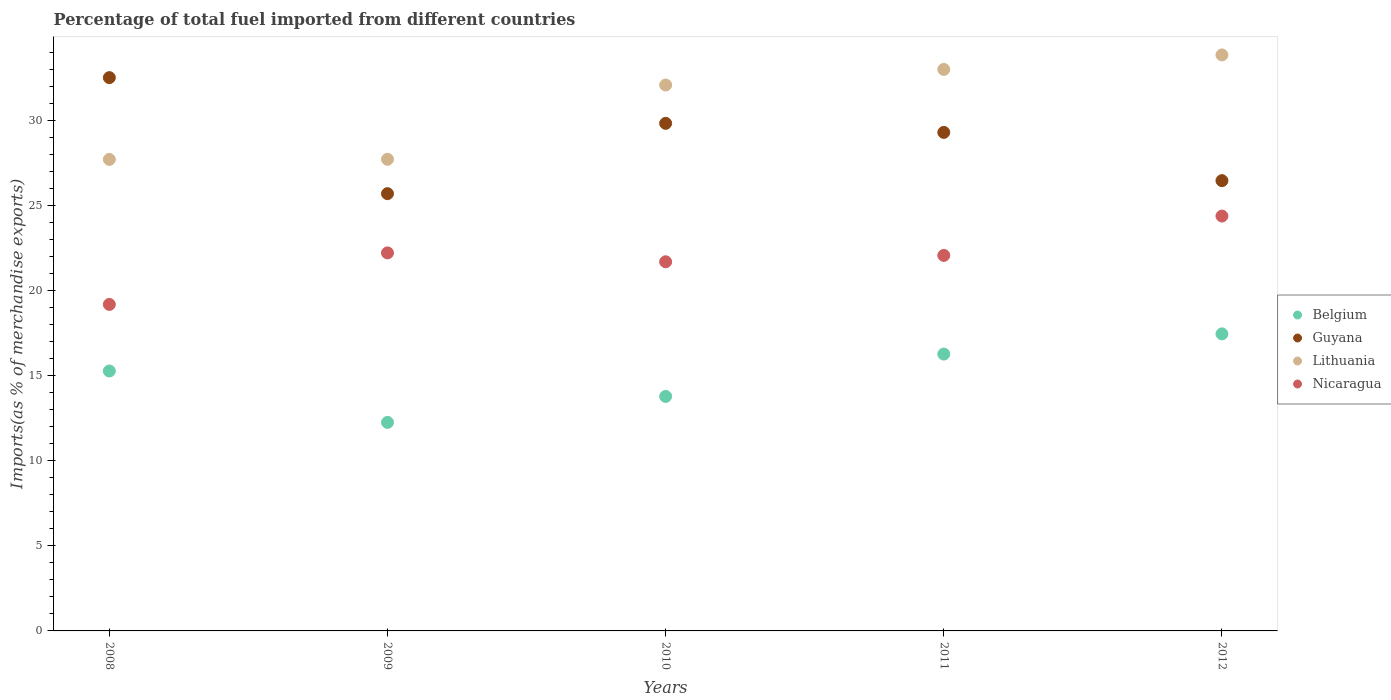Is the number of dotlines equal to the number of legend labels?
Your answer should be compact. Yes. What is the percentage of imports to different countries in Lithuania in 2009?
Make the answer very short. 27.74. Across all years, what is the maximum percentage of imports to different countries in Guyana?
Make the answer very short. 32.54. Across all years, what is the minimum percentage of imports to different countries in Nicaragua?
Provide a short and direct response. 19.2. In which year was the percentage of imports to different countries in Guyana maximum?
Keep it short and to the point. 2008. What is the total percentage of imports to different countries in Lithuania in the graph?
Offer a very short reply. 154.49. What is the difference between the percentage of imports to different countries in Lithuania in 2008 and that in 2010?
Give a very brief answer. -4.38. What is the difference between the percentage of imports to different countries in Belgium in 2011 and the percentage of imports to different countries in Nicaragua in 2009?
Your answer should be very brief. -5.95. What is the average percentage of imports to different countries in Guyana per year?
Provide a short and direct response. 28.78. In the year 2011, what is the difference between the percentage of imports to different countries in Belgium and percentage of imports to different countries in Nicaragua?
Provide a succinct answer. -5.8. What is the ratio of the percentage of imports to different countries in Belgium in 2008 to that in 2011?
Your answer should be very brief. 0.94. Is the percentage of imports to different countries in Belgium in 2008 less than that in 2010?
Your response must be concise. No. Is the difference between the percentage of imports to different countries in Belgium in 2010 and 2012 greater than the difference between the percentage of imports to different countries in Nicaragua in 2010 and 2012?
Your answer should be compact. No. What is the difference between the highest and the second highest percentage of imports to different countries in Guyana?
Offer a terse response. 2.69. What is the difference between the highest and the lowest percentage of imports to different countries in Lithuania?
Provide a short and direct response. 6.14. Is the sum of the percentage of imports to different countries in Nicaragua in 2008 and 2010 greater than the maximum percentage of imports to different countries in Belgium across all years?
Keep it short and to the point. Yes. Is it the case that in every year, the sum of the percentage of imports to different countries in Lithuania and percentage of imports to different countries in Nicaragua  is greater than the sum of percentage of imports to different countries in Belgium and percentage of imports to different countries in Guyana?
Your answer should be compact. Yes. Is the percentage of imports to different countries in Lithuania strictly greater than the percentage of imports to different countries in Belgium over the years?
Keep it short and to the point. Yes. How many dotlines are there?
Your response must be concise. 4. How many years are there in the graph?
Keep it short and to the point. 5. Where does the legend appear in the graph?
Keep it short and to the point. Center right. What is the title of the graph?
Your answer should be compact. Percentage of total fuel imported from different countries. What is the label or title of the Y-axis?
Your response must be concise. Imports(as % of merchandise exports). What is the Imports(as % of merchandise exports) of Belgium in 2008?
Your response must be concise. 15.29. What is the Imports(as % of merchandise exports) in Guyana in 2008?
Offer a very short reply. 32.54. What is the Imports(as % of merchandise exports) of Lithuania in 2008?
Your response must be concise. 27.73. What is the Imports(as % of merchandise exports) in Nicaragua in 2008?
Your answer should be compact. 19.2. What is the Imports(as % of merchandise exports) of Belgium in 2009?
Give a very brief answer. 12.27. What is the Imports(as % of merchandise exports) in Guyana in 2009?
Provide a short and direct response. 25.72. What is the Imports(as % of merchandise exports) of Lithuania in 2009?
Keep it short and to the point. 27.74. What is the Imports(as % of merchandise exports) in Nicaragua in 2009?
Your answer should be very brief. 22.24. What is the Imports(as % of merchandise exports) of Belgium in 2010?
Offer a terse response. 13.79. What is the Imports(as % of merchandise exports) of Guyana in 2010?
Your answer should be very brief. 29.85. What is the Imports(as % of merchandise exports) of Lithuania in 2010?
Keep it short and to the point. 32.11. What is the Imports(as % of merchandise exports) of Nicaragua in 2010?
Provide a succinct answer. 21.71. What is the Imports(as % of merchandise exports) of Belgium in 2011?
Offer a terse response. 16.28. What is the Imports(as % of merchandise exports) in Guyana in 2011?
Give a very brief answer. 29.32. What is the Imports(as % of merchandise exports) in Lithuania in 2011?
Offer a very short reply. 33.03. What is the Imports(as % of merchandise exports) of Nicaragua in 2011?
Offer a terse response. 22.09. What is the Imports(as % of merchandise exports) in Belgium in 2012?
Keep it short and to the point. 17.47. What is the Imports(as % of merchandise exports) in Guyana in 2012?
Your answer should be very brief. 26.48. What is the Imports(as % of merchandise exports) of Lithuania in 2012?
Give a very brief answer. 33.88. What is the Imports(as % of merchandise exports) of Nicaragua in 2012?
Your answer should be very brief. 24.4. Across all years, what is the maximum Imports(as % of merchandise exports) in Belgium?
Make the answer very short. 17.47. Across all years, what is the maximum Imports(as % of merchandise exports) of Guyana?
Give a very brief answer. 32.54. Across all years, what is the maximum Imports(as % of merchandise exports) of Lithuania?
Your answer should be very brief. 33.88. Across all years, what is the maximum Imports(as % of merchandise exports) in Nicaragua?
Offer a very short reply. 24.4. Across all years, what is the minimum Imports(as % of merchandise exports) in Belgium?
Your response must be concise. 12.27. Across all years, what is the minimum Imports(as % of merchandise exports) in Guyana?
Provide a succinct answer. 25.72. Across all years, what is the minimum Imports(as % of merchandise exports) of Lithuania?
Give a very brief answer. 27.73. Across all years, what is the minimum Imports(as % of merchandise exports) of Nicaragua?
Keep it short and to the point. 19.2. What is the total Imports(as % of merchandise exports) in Belgium in the graph?
Make the answer very short. 75.1. What is the total Imports(as % of merchandise exports) of Guyana in the graph?
Your answer should be very brief. 143.92. What is the total Imports(as % of merchandise exports) in Lithuania in the graph?
Provide a succinct answer. 154.49. What is the total Imports(as % of merchandise exports) of Nicaragua in the graph?
Provide a succinct answer. 109.64. What is the difference between the Imports(as % of merchandise exports) of Belgium in 2008 and that in 2009?
Keep it short and to the point. 3.02. What is the difference between the Imports(as % of merchandise exports) of Guyana in 2008 and that in 2009?
Provide a succinct answer. 6.82. What is the difference between the Imports(as % of merchandise exports) of Lithuania in 2008 and that in 2009?
Your answer should be compact. -0.01. What is the difference between the Imports(as % of merchandise exports) of Nicaragua in 2008 and that in 2009?
Offer a very short reply. -3.03. What is the difference between the Imports(as % of merchandise exports) in Belgium in 2008 and that in 2010?
Keep it short and to the point. 1.49. What is the difference between the Imports(as % of merchandise exports) of Guyana in 2008 and that in 2010?
Your answer should be very brief. 2.69. What is the difference between the Imports(as % of merchandise exports) of Lithuania in 2008 and that in 2010?
Ensure brevity in your answer.  -4.38. What is the difference between the Imports(as % of merchandise exports) of Nicaragua in 2008 and that in 2010?
Give a very brief answer. -2.51. What is the difference between the Imports(as % of merchandise exports) of Belgium in 2008 and that in 2011?
Offer a very short reply. -1. What is the difference between the Imports(as % of merchandise exports) in Guyana in 2008 and that in 2011?
Ensure brevity in your answer.  3.22. What is the difference between the Imports(as % of merchandise exports) in Lithuania in 2008 and that in 2011?
Your response must be concise. -5.29. What is the difference between the Imports(as % of merchandise exports) of Nicaragua in 2008 and that in 2011?
Offer a very short reply. -2.88. What is the difference between the Imports(as % of merchandise exports) in Belgium in 2008 and that in 2012?
Provide a succinct answer. -2.18. What is the difference between the Imports(as % of merchandise exports) of Guyana in 2008 and that in 2012?
Your response must be concise. 6.06. What is the difference between the Imports(as % of merchandise exports) of Lithuania in 2008 and that in 2012?
Ensure brevity in your answer.  -6.14. What is the difference between the Imports(as % of merchandise exports) of Nicaragua in 2008 and that in 2012?
Keep it short and to the point. -5.2. What is the difference between the Imports(as % of merchandise exports) in Belgium in 2009 and that in 2010?
Your answer should be very brief. -1.53. What is the difference between the Imports(as % of merchandise exports) of Guyana in 2009 and that in 2010?
Give a very brief answer. -4.14. What is the difference between the Imports(as % of merchandise exports) of Lithuania in 2009 and that in 2010?
Your answer should be compact. -4.37. What is the difference between the Imports(as % of merchandise exports) in Nicaragua in 2009 and that in 2010?
Ensure brevity in your answer.  0.52. What is the difference between the Imports(as % of merchandise exports) in Belgium in 2009 and that in 2011?
Your answer should be compact. -4.02. What is the difference between the Imports(as % of merchandise exports) in Guyana in 2009 and that in 2011?
Make the answer very short. -3.6. What is the difference between the Imports(as % of merchandise exports) in Lithuania in 2009 and that in 2011?
Offer a very short reply. -5.29. What is the difference between the Imports(as % of merchandise exports) of Nicaragua in 2009 and that in 2011?
Ensure brevity in your answer.  0.15. What is the difference between the Imports(as % of merchandise exports) in Belgium in 2009 and that in 2012?
Provide a succinct answer. -5.21. What is the difference between the Imports(as % of merchandise exports) in Guyana in 2009 and that in 2012?
Give a very brief answer. -0.76. What is the difference between the Imports(as % of merchandise exports) of Lithuania in 2009 and that in 2012?
Offer a terse response. -6.14. What is the difference between the Imports(as % of merchandise exports) in Nicaragua in 2009 and that in 2012?
Give a very brief answer. -2.17. What is the difference between the Imports(as % of merchandise exports) in Belgium in 2010 and that in 2011?
Provide a succinct answer. -2.49. What is the difference between the Imports(as % of merchandise exports) in Guyana in 2010 and that in 2011?
Your answer should be very brief. 0.53. What is the difference between the Imports(as % of merchandise exports) in Lithuania in 2010 and that in 2011?
Provide a succinct answer. -0.92. What is the difference between the Imports(as % of merchandise exports) in Nicaragua in 2010 and that in 2011?
Make the answer very short. -0.37. What is the difference between the Imports(as % of merchandise exports) in Belgium in 2010 and that in 2012?
Your answer should be very brief. -3.68. What is the difference between the Imports(as % of merchandise exports) in Guyana in 2010 and that in 2012?
Provide a short and direct response. 3.37. What is the difference between the Imports(as % of merchandise exports) of Lithuania in 2010 and that in 2012?
Your response must be concise. -1.77. What is the difference between the Imports(as % of merchandise exports) of Nicaragua in 2010 and that in 2012?
Ensure brevity in your answer.  -2.69. What is the difference between the Imports(as % of merchandise exports) in Belgium in 2011 and that in 2012?
Keep it short and to the point. -1.19. What is the difference between the Imports(as % of merchandise exports) in Guyana in 2011 and that in 2012?
Keep it short and to the point. 2.84. What is the difference between the Imports(as % of merchandise exports) in Lithuania in 2011 and that in 2012?
Offer a terse response. -0.85. What is the difference between the Imports(as % of merchandise exports) in Nicaragua in 2011 and that in 2012?
Give a very brief answer. -2.31. What is the difference between the Imports(as % of merchandise exports) of Belgium in 2008 and the Imports(as % of merchandise exports) of Guyana in 2009?
Your response must be concise. -10.43. What is the difference between the Imports(as % of merchandise exports) in Belgium in 2008 and the Imports(as % of merchandise exports) in Lithuania in 2009?
Give a very brief answer. -12.45. What is the difference between the Imports(as % of merchandise exports) in Belgium in 2008 and the Imports(as % of merchandise exports) in Nicaragua in 2009?
Offer a very short reply. -6.95. What is the difference between the Imports(as % of merchandise exports) of Guyana in 2008 and the Imports(as % of merchandise exports) of Lithuania in 2009?
Give a very brief answer. 4.8. What is the difference between the Imports(as % of merchandise exports) in Guyana in 2008 and the Imports(as % of merchandise exports) in Nicaragua in 2009?
Provide a short and direct response. 10.31. What is the difference between the Imports(as % of merchandise exports) in Lithuania in 2008 and the Imports(as % of merchandise exports) in Nicaragua in 2009?
Offer a terse response. 5.5. What is the difference between the Imports(as % of merchandise exports) of Belgium in 2008 and the Imports(as % of merchandise exports) of Guyana in 2010?
Offer a terse response. -14.57. What is the difference between the Imports(as % of merchandise exports) of Belgium in 2008 and the Imports(as % of merchandise exports) of Lithuania in 2010?
Offer a terse response. -16.82. What is the difference between the Imports(as % of merchandise exports) of Belgium in 2008 and the Imports(as % of merchandise exports) of Nicaragua in 2010?
Give a very brief answer. -6.42. What is the difference between the Imports(as % of merchandise exports) in Guyana in 2008 and the Imports(as % of merchandise exports) in Lithuania in 2010?
Ensure brevity in your answer.  0.43. What is the difference between the Imports(as % of merchandise exports) in Guyana in 2008 and the Imports(as % of merchandise exports) in Nicaragua in 2010?
Your answer should be compact. 10.83. What is the difference between the Imports(as % of merchandise exports) in Lithuania in 2008 and the Imports(as % of merchandise exports) in Nicaragua in 2010?
Your response must be concise. 6.02. What is the difference between the Imports(as % of merchandise exports) in Belgium in 2008 and the Imports(as % of merchandise exports) in Guyana in 2011?
Your response must be concise. -14.03. What is the difference between the Imports(as % of merchandise exports) in Belgium in 2008 and the Imports(as % of merchandise exports) in Lithuania in 2011?
Provide a succinct answer. -17.74. What is the difference between the Imports(as % of merchandise exports) in Belgium in 2008 and the Imports(as % of merchandise exports) in Nicaragua in 2011?
Keep it short and to the point. -6.8. What is the difference between the Imports(as % of merchandise exports) in Guyana in 2008 and the Imports(as % of merchandise exports) in Lithuania in 2011?
Provide a short and direct response. -0.48. What is the difference between the Imports(as % of merchandise exports) in Guyana in 2008 and the Imports(as % of merchandise exports) in Nicaragua in 2011?
Provide a short and direct response. 10.46. What is the difference between the Imports(as % of merchandise exports) in Lithuania in 2008 and the Imports(as % of merchandise exports) in Nicaragua in 2011?
Provide a succinct answer. 5.65. What is the difference between the Imports(as % of merchandise exports) in Belgium in 2008 and the Imports(as % of merchandise exports) in Guyana in 2012?
Your answer should be compact. -11.2. What is the difference between the Imports(as % of merchandise exports) in Belgium in 2008 and the Imports(as % of merchandise exports) in Lithuania in 2012?
Make the answer very short. -18.59. What is the difference between the Imports(as % of merchandise exports) of Belgium in 2008 and the Imports(as % of merchandise exports) of Nicaragua in 2012?
Ensure brevity in your answer.  -9.11. What is the difference between the Imports(as % of merchandise exports) of Guyana in 2008 and the Imports(as % of merchandise exports) of Lithuania in 2012?
Provide a succinct answer. -1.33. What is the difference between the Imports(as % of merchandise exports) in Guyana in 2008 and the Imports(as % of merchandise exports) in Nicaragua in 2012?
Offer a very short reply. 8.14. What is the difference between the Imports(as % of merchandise exports) in Lithuania in 2008 and the Imports(as % of merchandise exports) in Nicaragua in 2012?
Make the answer very short. 3.33. What is the difference between the Imports(as % of merchandise exports) of Belgium in 2009 and the Imports(as % of merchandise exports) of Guyana in 2010?
Keep it short and to the point. -17.59. What is the difference between the Imports(as % of merchandise exports) in Belgium in 2009 and the Imports(as % of merchandise exports) in Lithuania in 2010?
Your response must be concise. -19.84. What is the difference between the Imports(as % of merchandise exports) of Belgium in 2009 and the Imports(as % of merchandise exports) of Nicaragua in 2010?
Your response must be concise. -9.45. What is the difference between the Imports(as % of merchandise exports) of Guyana in 2009 and the Imports(as % of merchandise exports) of Lithuania in 2010?
Your answer should be compact. -6.39. What is the difference between the Imports(as % of merchandise exports) of Guyana in 2009 and the Imports(as % of merchandise exports) of Nicaragua in 2010?
Keep it short and to the point. 4.01. What is the difference between the Imports(as % of merchandise exports) of Lithuania in 2009 and the Imports(as % of merchandise exports) of Nicaragua in 2010?
Make the answer very short. 6.03. What is the difference between the Imports(as % of merchandise exports) in Belgium in 2009 and the Imports(as % of merchandise exports) in Guyana in 2011?
Provide a succinct answer. -17.06. What is the difference between the Imports(as % of merchandise exports) in Belgium in 2009 and the Imports(as % of merchandise exports) in Lithuania in 2011?
Offer a terse response. -20.76. What is the difference between the Imports(as % of merchandise exports) in Belgium in 2009 and the Imports(as % of merchandise exports) in Nicaragua in 2011?
Your response must be concise. -9.82. What is the difference between the Imports(as % of merchandise exports) in Guyana in 2009 and the Imports(as % of merchandise exports) in Lithuania in 2011?
Keep it short and to the point. -7.31. What is the difference between the Imports(as % of merchandise exports) of Guyana in 2009 and the Imports(as % of merchandise exports) of Nicaragua in 2011?
Your answer should be very brief. 3.63. What is the difference between the Imports(as % of merchandise exports) in Lithuania in 2009 and the Imports(as % of merchandise exports) in Nicaragua in 2011?
Offer a terse response. 5.65. What is the difference between the Imports(as % of merchandise exports) in Belgium in 2009 and the Imports(as % of merchandise exports) in Guyana in 2012?
Ensure brevity in your answer.  -14.22. What is the difference between the Imports(as % of merchandise exports) in Belgium in 2009 and the Imports(as % of merchandise exports) in Lithuania in 2012?
Provide a succinct answer. -21.61. What is the difference between the Imports(as % of merchandise exports) in Belgium in 2009 and the Imports(as % of merchandise exports) in Nicaragua in 2012?
Offer a terse response. -12.14. What is the difference between the Imports(as % of merchandise exports) of Guyana in 2009 and the Imports(as % of merchandise exports) of Lithuania in 2012?
Your answer should be very brief. -8.16. What is the difference between the Imports(as % of merchandise exports) in Guyana in 2009 and the Imports(as % of merchandise exports) in Nicaragua in 2012?
Your answer should be compact. 1.32. What is the difference between the Imports(as % of merchandise exports) of Lithuania in 2009 and the Imports(as % of merchandise exports) of Nicaragua in 2012?
Your answer should be compact. 3.34. What is the difference between the Imports(as % of merchandise exports) in Belgium in 2010 and the Imports(as % of merchandise exports) in Guyana in 2011?
Keep it short and to the point. -15.53. What is the difference between the Imports(as % of merchandise exports) of Belgium in 2010 and the Imports(as % of merchandise exports) of Lithuania in 2011?
Your response must be concise. -19.23. What is the difference between the Imports(as % of merchandise exports) in Belgium in 2010 and the Imports(as % of merchandise exports) in Nicaragua in 2011?
Provide a succinct answer. -8.29. What is the difference between the Imports(as % of merchandise exports) in Guyana in 2010 and the Imports(as % of merchandise exports) in Lithuania in 2011?
Keep it short and to the point. -3.17. What is the difference between the Imports(as % of merchandise exports) in Guyana in 2010 and the Imports(as % of merchandise exports) in Nicaragua in 2011?
Your answer should be very brief. 7.77. What is the difference between the Imports(as % of merchandise exports) in Lithuania in 2010 and the Imports(as % of merchandise exports) in Nicaragua in 2011?
Your answer should be very brief. 10.02. What is the difference between the Imports(as % of merchandise exports) in Belgium in 2010 and the Imports(as % of merchandise exports) in Guyana in 2012?
Provide a short and direct response. -12.69. What is the difference between the Imports(as % of merchandise exports) of Belgium in 2010 and the Imports(as % of merchandise exports) of Lithuania in 2012?
Provide a succinct answer. -20.08. What is the difference between the Imports(as % of merchandise exports) of Belgium in 2010 and the Imports(as % of merchandise exports) of Nicaragua in 2012?
Your answer should be very brief. -10.61. What is the difference between the Imports(as % of merchandise exports) of Guyana in 2010 and the Imports(as % of merchandise exports) of Lithuania in 2012?
Your answer should be compact. -4.02. What is the difference between the Imports(as % of merchandise exports) of Guyana in 2010 and the Imports(as % of merchandise exports) of Nicaragua in 2012?
Your answer should be very brief. 5.45. What is the difference between the Imports(as % of merchandise exports) in Lithuania in 2010 and the Imports(as % of merchandise exports) in Nicaragua in 2012?
Your answer should be compact. 7.71. What is the difference between the Imports(as % of merchandise exports) in Belgium in 2011 and the Imports(as % of merchandise exports) in Guyana in 2012?
Make the answer very short. -10.2. What is the difference between the Imports(as % of merchandise exports) of Belgium in 2011 and the Imports(as % of merchandise exports) of Lithuania in 2012?
Provide a short and direct response. -17.59. What is the difference between the Imports(as % of merchandise exports) of Belgium in 2011 and the Imports(as % of merchandise exports) of Nicaragua in 2012?
Provide a short and direct response. -8.12. What is the difference between the Imports(as % of merchandise exports) of Guyana in 2011 and the Imports(as % of merchandise exports) of Lithuania in 2012?
Your answer should be very brief. -4.56. What is the difference between the Imports(as % of merchandise exports) of Guyana in 2011 and the Imports(as % of merchandise exports) of Nicaragua in 2012?
Make the answer very short. 4.92. What is the difference between the Imports(as % of merchandise exports) in Lithuania in 2011 and the Imports(as % of merchandise exports) in Nicaragua in 2012?
Ensure brevity in your answer.  8.63. What is the average Imports(as % of merchandise exports) of Belgium per year?
Your answer should be compact. 15.02. What is the average Imports(as % of merchandise exports) in Guyana per year?
Offer a terse response. 28.78. What is the average Imports(as % of merchandise exports) in Lithuania per year?
Your response must be concise. 30.9. What is the average Imports(as % of merchandise exports) of Nicaragua per year?
Provide a short and direct response. 21.93. In the year 2008, what is the difference between the Imports(as % of merchandise exports) in Belgium and Imports(as % of merchandise exports) in Guyana?
Your answer should be very brief. -17.26. In the year 2008, what is the difference between the Imports(as % of merchandise exports) in Belgium and Imports(as % of merchandise exports) in Lithuania?
Make the answer very short. -12.45. In the year 2008, what is the difference between the Imports(as % of merchandise exports) of Belgium and Imports(as % of merchandise exports) of Nicaragua?
Provide a succinct answer. -3.92. In the year 2008, what is the difference between the Imports(as % of merchandise exports) of Guyana and Imports(as % of merchandise exports) of Lithuania?
Your answer should be compact. 4.81. In the year 2008, what is the difference between the Imports(as % of merchandise exports) in Guyana and Imports(as % of merchandise exports) in Nicaragua?
Ensure brevity in your answer.  13.34. In the year 2008, what is the difference between the Imports(as % of merchandise exports) in Lithuania and Imports(as % of merchandise exports) in Nicaragua?
Your answer should be compact. 8.53. In the year 2009, what is the difference between the Imports(as % of merchandise exports) of Belgium and Imports(as % of merchandise exports) of Guyana?
Provide a succinct answer. -13.45. In the year 2009, what is the difference between the Imports(as % of merchandise exports) in Belgium and Imports(as % of merchandise exports) in Lithuania?
Your answer should be compact. -15.47. In the year 2009, what is the difference between the Imports(as % of merchandise exports) in Belgium and Imports(as % of merchandise exports) in Nicaragua?
Your response must be concise. -9.97. In the year 2009, what is the difference between the Imports(as % of merchandise exports) in Guyana and Imports(as % of merchandise exports) in Lithuania?
Provide a succinct answer. -2.02. In the year 2009, what is the difference between the Imports(as % of merchandise exports) of Guyana and Imports(as % of merchandise exports) of Nicaragua?
Provide a succinct answer. 3.48. In the year 2009, what is the difference between the Imports(as % of merchandise exports) of Lithuania and Imports(as % of merchandise exports) of Nicaragua?
Make the answer very short. 5.51. In the year 2010, what is the difference between the Imports(as % of merchandise exports) in Belgium and Imports(as % of merchandise exports) in Guyana?
Give a very brief answer. -16.06. In the year 2010, what is the difference between the Imports(as % of merchandise exports) of Belgium and Imports(as % of merchandise exports) of Lithuania?
Keep it short and to the point. -18.32. In the year 2010, what is the difference between the Imports(as % of merchandise exports) of Belgium and Imports(as % of merchandise exports) of Nicaragua?
Ensure brevity in your answer.  -7.92. In the year 2010, what is the difference between the Imports(as % of merchandise exports) of Guyana and Imports(as % of merchandise exports) of Lithuania?
Give a very brief answer. -2.25. In the year 2010, what is the difference between the Imports(as % of merchandise exports) of Guyana and Imports(as % of merchandise exports) of Nicaragua?
Keep it short and to the point. 8.14. In the year 2010, what is the difference between the Imports(as % of merchandise exports) in Lithuania and Imports(as % of merchandise exports) in Nicaragua?
Your answer should be very brief. 10.4. In the year 2011, what is the difference between the Imports(as % of merchandise exports) of Belgium and Imports(as % of merchandise exports) of Guyana?
Make the answer very short. -13.04. In the year 2011, what is the difference between the Imports(as % of merchandise exports) in Belgium and Imports(as % of merchandise exports) in Lithuania?
Your answer should be very brief. -16.74. In the year 2011, what is the difference between the Imports(as % of merchandise exports) of Belgium and Imports(as % of merchandise exports) of Nicaragua?
Offer a very short reply. -5.8. In the year 2011, what is the difference between the Imports(as % of merchandise exports) in Guyana and Imports(as % of merchandise exports) in Lithuania?
Provide a short and direct response. -3.71. In the year 2011, what is the difference between the Imports(as % of merchandise exports) of Guyana and Imports(as % of merchandise exports) of Nicaragua?
Provide a succinct answer. 7.24. In the year 2011, what is the difference between the Imports(as % of merchandise exports) of Lithuania and Imports(as % of merchandise exports) of Nicaragua?
Make the answer very short. 10.94. In the year 2012, what is the difference between the Imports(as % of merchandise exports) of Belgium and Imports(as % of merchandise exports) of Guyana?
Your response must be concise. -9.01. In the year 2012, what is the difference between the Imports(as % of merchandise exports) in Belgium and Imports(as % of merchandise exports) in Lithuania?
Make the answer very short. -16.41. In the year 2012, what is the difference between the Imports(as % of merchandise exports) in Belgium and Imports(as % of merchandise exports) in Nicaragua?
Ensure brevity in your answer.  -6.93. In the year 2012, what is the difference between the Imports(as % of merchandise exports) in Guyana and Imports(as % of merchandise exports) in Lithuania?
Your response must be concise. -7.39. In the year 2012, what is the difference between the Imports(as % of merchandise exports) in Guyana and Imports(as % of merchandise exports) in Nicaragua?
Provide a short and direct response. 2.08. In the year 2012, what is the difference between the Imports(as % of merchandise exports) in Lithuania and Imports(as % of merchandise exports) in Nicaragua?
Your answer should be very brief. 9.48. What is the ratio of the Imports(as % of merchandise exports) in Belgium in 2008 to that in 2009?
Make the answer very short. 1.25. What is the ratio of the Imports(as % of merchandise exports) in Guyana in 2008 to that in 2009?
Offer a terse response. 1.27. What is the ratio of the Imports(as % of merchandise exports) of Lithuania in 2008 to that in 2009?
Provide a short and direct response. 1. What is the ratio of the Imports(as % of merchandise exports) in Nicaragua in 2008 to that in 2009?
Your answer should be very brief. 0.86. What is the ratio of the Imports(as % of merchandise exports) in Belgium in 2008 to that in 2010?
Keep it short and to the point. 1.11. What is the ratio of the Imports(as % of merchandise exports) of Guyana in 2008 to that in 2010?
Offer a very short reply. 1.09. What is the ratio of the Imports(as % of merchandise exports) in Lithuania in 2008 to that in 2010?
Your answer should be compact. 0.86. What is the ratio of the Imports(as % of merchandise exports) in Nicaragua in 2008 to that in 2010?
Keep it short and to the point. 0.88. What is the ratio of the Imports(as % of merchandise exports) in Belgium in 2008 to that in 2011?
Your answer should be very brief. 0.94. What is the ratio of the Imports(as % of merchandise exports) of Guyana in 2008 to that in 2011?
Provide a succinct answer. 1.11. What is the ratio of the Imports(as % of merchandise exports) of Lithuania in 2008 to that in 2011?
Give a very brief answer. 0.84. What is the ratio of the Imports(as % of merchandise exports) in Nicaragua in 2008 to that in 2011?
Provide a short and direct response. 0.87. What is the ratio of the Imports(as % of merchandise exports) of Belgium in 2008 to that in 2012?
Your answer should be compact. 0.88. What is the ratio of the Imports(as % of merchandise exports) in Guyana in 2008 to that in 2012?
Keep it short and to the point. 1.23. What is the ratio of the Imports(as % of merchandise exports) of Lithuania in 2008 to that in 2012?
Give a very brief answer. 0.82. What is the ratio of the Imports(as % of merchandise exports) in Nicaragua in 2008 to that in 2012?
Provide a short and direct response. 0.79. What is the ratio of the Imports(as % of merchandise exports) in Belgium in 2009 to that in 2010?
Make the answer very short. 0.89. What is the ratio of the Imports(as % of merchandise exports) of Guyana in 2009 to that in 2010?
Give a very brief answer. 0.86. What is the ratio of the Imports(as % of merchandise exports) in Lithuania in 2009 to that in 2010?
Offer a very short reply. 0.86. What is the ratio of the Imports(as % of merchandise exports) in Nicaragua in 2009 to that in 2010?
Provide a succinct answer. 1.02. What is the ratio of the Imports(as % of merchandise exports) of Belgium in 2009 to that in 2011?
Offer a very short reply. 0.75. What is the ratio of the Imports(as % of merchandise exports) of Guyana in 2009 to that in 2011?
Keep it short and to the point. 0.88. What is the ratio of the Imports(as % of merchandise exports) of Lithuania in 2009 to that in 2011?
Ensure brevity in your answer.  0.84. What is the ratio of the Imports(as % of merchandise exports) in Belgium in 2009 to that in 2012?
Offer a very short reply. 0.7. What is the ratio of the Imports(as % of merchandise exports) in Guyana in 2009 to that in 2012?
Ensure brevity in your answer.  0.97. What is the ratio of the Imports(as % of merchandise exports) of Lithuania in 2009 to that in 2012?
Give a very brief answer. 0.82. What is the ratio of the Imports(as % of merchandise exports) in Nicaragua in 2009 to that in 2012?
Offer a very short reply. 0.91. What is the ratio of the Imports(as % of merchandise exports) in Belgium in 2010 to that in 2011?
Give a very brief answer. 0.85. What is the ratio of the Imports(as % of merchandise exports) of Guyana in 2010 to that in 2011?
Ensure brevity in your answer.  1.02. What is the ratio of the Imports(as % of merchandise exports) of Lithuania in 2010 to that in 2011?
Ensure brevity in your answer.  0.97. What is the ratio of the Imports(as % of merchandise exports) of Belgium in 2010 to that in 2012?
Offer a terse response. 0.79. What is the ratio of the Imports(as % of merchandise exports) of Guyana in 2010 to that in 2012?
Your response must be concise. 1.13. What is the ratio of the Imports(as % of merchandise exports) in Lithuania in 2010 to that in 2012?
Your response must be concise. 0.95. What is the ratio of the Imports(as % of merchandise exports) in Nicaragua in 2010 to that in 2012?
Provide a short and direct response. 0.89. What is the ratio of the Imports(as % of merchandise exports) of Belgium in 2011 to that in 2012?
Provide a short and direct response. 0.93. What is the ratio of the Imports(as % of merchandise exports) of Guyana in 2011 to that in 2012?
Offer a very short reply. 1.11. What is the ratio of the Imports(as % of merchandise exports) in Lithuania in 2011 to that in 2012?
Your response must be concise. 0.97. What is the ratio of the Imports(as % of merchandise exports) in Nicaragua in 2011 to that in 2012?
Offer a terse response. 0.91. What is the difference between the highest and the second highest Imports(as % of merchandise exports) in Belgium?
Make the answer very short. 1.19. What is the difference between the highest and the second highest Imports(as % of merchandise exports) in Guyana?
Offer a terse response. 2.69. What is the difference between the highest and the second highest Imports(as % of merchandise exports) of Lithuania?
Offer a very short reply. 0.85. What is the difference between the highest and the second highest Imports(as % of merchandise exports) of Nicaragua?
Give a very brief answer. 2.17. What is the difference between the highest and the lowest Imports(as % of merchandise exports) of Belgium?
Offer a terse response. 5.21. What is the difference between the highest and the lowest Imports(as % of merchandise exports) of Guyana?
Your response must be concise. 6.82. What is the difference between the highest and the lowest Imports(as % of merchandise exports) of Lithuania?
Make the answer very short. 6.14. What is the difference between the highest and the lowest Imports(as % of merchandise exports) in Nicaragua?
Offer a very short reply. 5.2. 